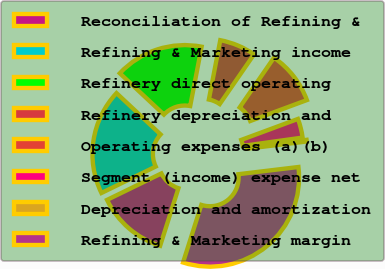Convert chart to OTSL. <chart><loc_0><loc_0><loc_500><loc_500><pie_chart><fcel>Reconciliation of Refining &<fcel>Refining & Marketing income<fcel>Refinery direct operating<fcel>Refinery depreciation and<fcel>Operating expenses (a)(b)<fcel>Segment (income) expense net<fcel>Depreciation and amortization<fcel>Refining & Marketing margin<nl><fcel>12.89%<fcel>19.19%<fcel>16.04%<fcel>6.59%<fcel>9.74%<fcel>3.44%<fcel>0.3%<fcel>31.79%<nl></chart> 